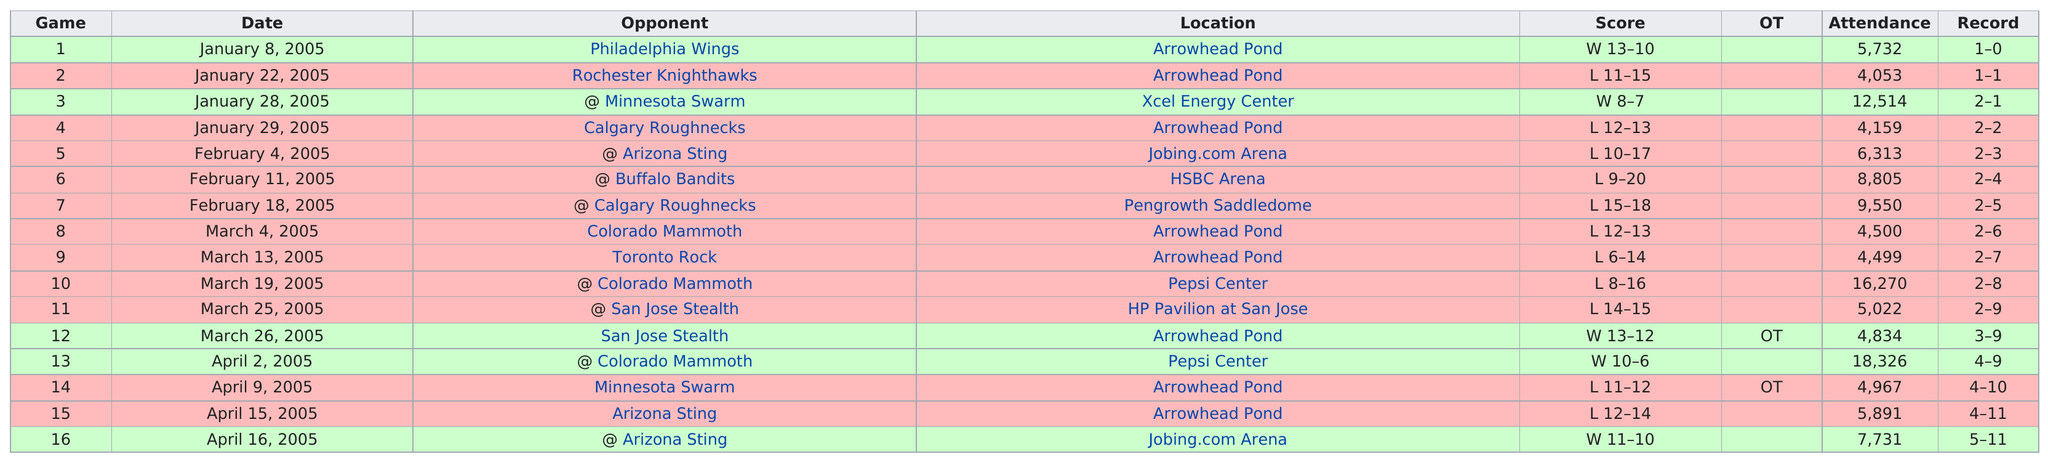Specify some key components in this picture. The team had won two games before March 4, 2005. The total amount of games that the team won by more than 2 points is 2.. Out of the total number of games played, how many had at least 10,000 people in attendance? The Anaheim Storm won more away games than they did home games. A total of 8 games were held at Arrowhead Pond. 